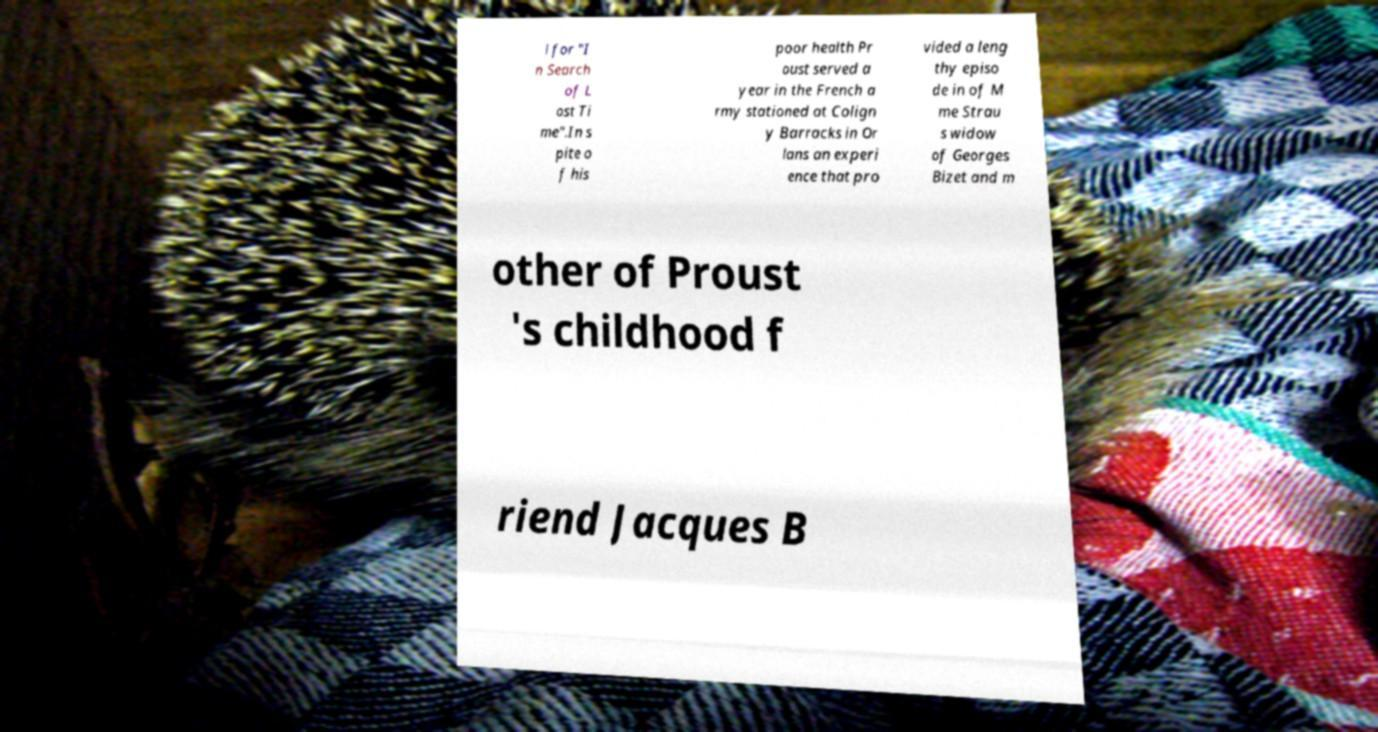There's text embedded in this image that I need extracted. Can you transcribe it verbatim? l for "I n Search of L ost Ti me".In s pite o f his poor health Pr oust served a year in the French a rmy stationed at Colign y Barracks in Or lans an experi ence that pro vided a leng thy episo de in of M me Strau s widow of Georges Bizet and m other of Proust 's childhood f riend Jacques B 